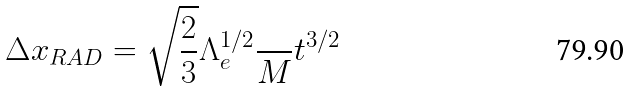<formula> <loc_0><loc_0><loc_500><loc_500>\Delta x _ { R A D } = \sqrt { \frac { 2 } { 3 } } \Lambda _ { e } ^ { 1 / 2 } \frac { } { M } t ^ { 3 / 2 }</formula> 